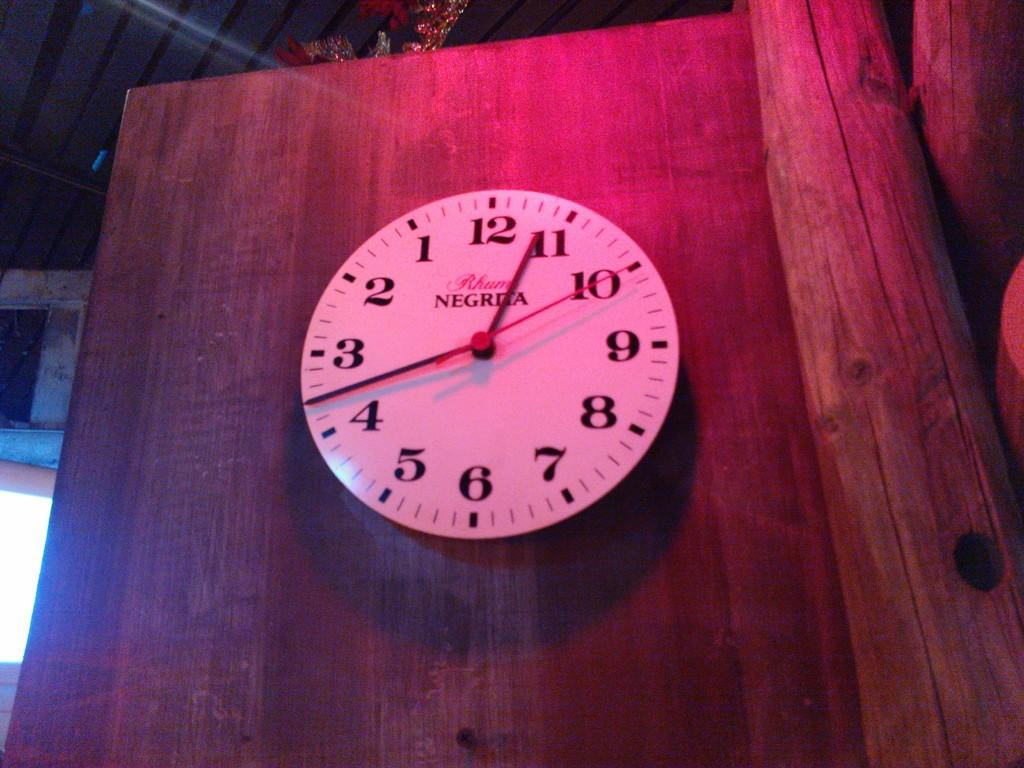<image>
Share a concise interpretation of the image provided. A Negrita clock is hanging on a wooden wall. 